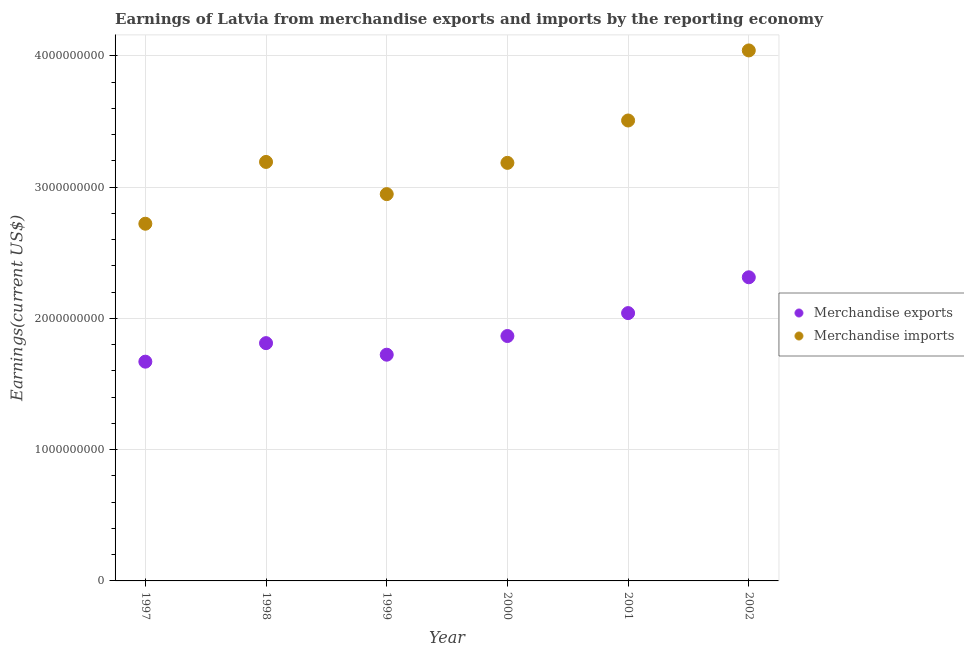How many different coloured dotlines are there?
Ensure brevity in your answer.  2. Is the number of dotlines equal to the number of legend labels?
Offer a very short reply. Yes. What is the earnings from merchandise imports in 1998?
Offer a terse response. 3.19e+09. Across all years, what is the maximum earnings from merchandise exports?
Your answer should be very brief. 2.31e+09. Across all years, what is the minimum earnings from merchandise imports?
Make the answer very short. 2.72e+09. In which year was the earnings from merchandise exports maximum?
Your answer should be very brief. 2002. What is the total earnings from merchandise exports in the graph?
Offer a very short reply. 1.14e+1. What is the difference between the earnings from merchandise exports in 1997 and that in 2001?
Make the answer very short. -3.70e+08. What is the difference between the earnings from merchandise exports in 2001 and the earnings from merchandise imports in 1999?
Provide a short and direct response. -9.06e+08. What is the average earnings from merchandise exports per year?
Give a very brief answer. 1.90e+09. In the year 2001, what is the difference between the earnings from merchandise exports and earnings from merchandise imports?
Keep it short and to the point. -1.47e+09. What is the ratio of the earnings from merchandise exports in 1998 to that in 2002?
Give a very brief answer. 0.78. Is the difference between the earnings from merchandise exports in 1997 and 1998 greater than the difference between the earnings from merchandise imports in 1997 and 1998?
Your response must be concise. Yes. What is the difference between the highest and the second highest earnings from merchandise exports?
Offer a very short reply. 2.73e+08. What is the difference between the highest and the lowest earnings from merchandise imports?
Keep it short and to the point. 1.32e+09. In how many years, is the earnings from merchandise imports greater than the average earnings from merchandise imports taken over all years?
Ensure brevity in your answer.  2. Is the sum of the earnings from merchandise imports in 1998 and 2001 greater than the maximum earnings from merchandise exports across all years?
Offer a very short reply. Yes. Is the earnings from merchandise imports strictly greater than the earnings from merchandise exports over the years?
Keep it short and to the point. Yes. Is the earnings from merchandise exports strictly less than the earnings from merchandise imports over the years?
Offer a very short reply. Yes. What is the difference between two consecutive major ticks on the Y-axis?
Make the answer very short. 1.00e+09. Does the graph contain grids?
Offer a very short reply. Yes. How many legend labels are there?
Give a very brief answer. 2. What is the title of the graph?
Keep it short and to the point. Earnings of Latvia from merchandise exports and imports by the reporting economy. Does "Start a business" appear as one of the legend labels in the graph?
Offer a very short reply. No. What is the label or title of the Y-axis?
Your response must be concise. Earnings(current US$). What is the Earnings(current US$) in Merchandise exports in 1997?
Make the answer very short. 1.67e+09. What is the Earnings(current US$) in Merchandise imports in 1997?
Make the answer very short. 2.72e+09. What is the Earnings(current US$) of Merchandise exports in 1998?
Your answer should be compact. 1.81e+09. What is the Earnings(current US$) in Merchandise imports in 1998?
Offer a terse response. 3.19e+09. What is the Earnings(current US$) in Merchandise exports in 1999?
Offer a terse response. 1.72e+09. What is the Earnings(current US$) of Merchandise imports in 1999?
Ensure brevity in your answer.  2.95e+09. What is the Earnings(current US$) of Merchandise exports in 2000?
Make the answer very short. 1.87e+09. What is the Earnings(current US$) of Merchandise imports in 2000?
Offer a terse response. 3.18e+09. What is the Earnings(current US$) in Merchandise exports in 2001?
Give a very brief answer. 2.04e+09. What is the Earnings(current US$) in Merchandise imports in 2001?
Keep it short and to the point. 3.51e+09. What is the Earnings(current US$) in Merchandise exports in 2002?
Your answer should be very brief. 2.31e+09. What is the Earnings(current US$) in Merchandise imports in 2002?
Give a very brief answer. 4.04e+09. Across all years, what is the maximum Earnings(current US$) in Merchandise exports?
Make the answer very short. 2.31e+09. Across all years, what is the maximum Earnings(current US$) in Merchandise imports?
Your response must be concise. 4.04e+09. Across all years, what is the minimum Earnings(current US$) in Merchandise exports?
Make the answer very short. 1.67e+09. Across all years, what is the minimum Earnings(current US$) of Merchandise imports?
Give a very brief answer. 2.72e+09. What is the total Earnings(current US$) of Merchandise exports in the graph?
Ensure brevity in your answer.  1.14e+1. What is the total Earnings(current US$) in Merchandise imports in the graph?
Keep it short and to the point. 1.96e+1. What is the difference between the Earnings(current US$) in Merchandise exports in 1997 and that in 1998?
Offer a very short reply. -1.41e+08. What is the difference between the Earnings(current US$) in Merchandise imports in 1997 and that in 1998?
Offer a terse response. -4.71e+08. What is the difference between the Earnings(current US$) in Merchandise exports in 1997 and that in 1999?
Your response must be concise. -5.31e+07. What is the difference between the Earnings(current US$) in Merchandise imports in 1997 and that in 1999?
Keep it short and to the point. -2.25e+08. What is the difference between the Earnings(current US$) of Merchandise exports in 1997 and that in 2000?
Give a very brief answer. -1.95e+08. What is the difference between the Earnings(current US$) of Merchandise imports in 1997 and that in 2000?
Offer a very short reply. -4.64e+08. What is the difference between the Earnings(current US$) of Merchandise exports in 1997 and that in 2001?
Keep it short and to the point. -3.70e+08. What is the difference between the Earnings(current US$) in Merchandise imports in 1997 and that in 2001?
Your response must be concise. -7.86e+08. What is the difference between the Earnings(current US$) in Merchandise exports in 1997 and that in 2002?
Ensure brevity in your answer.  -6.43e+08. What is the difference between the Earnings(current US$) of Merchandise imports in 1997 and that in 2002?
Ensure brevity in your answer.  -1.32e+09. What is the difference between the Earnings(current US$) in Merchandise exports in 1998 and that in 1999?
Ensure brevity in your answer.  8.81e+07. What is the difference between the Earnings(current US$) in Merchandise imports in 1998 and that in 1999?
Offer a terse response. 2.45e+08. What is the difference between the Earnings(current US$) in Merchandise exports in 1998 and that in 2000?
Provide a succinct answer. -5.42e+07. What is the difference between the Earnings(current US$) of Merchandise imports in 1998 and that in 2000?
Your answer should be compact. 7.06e+06. What is the difference between the Earnings(current US$) of Merchandise exports in 1998 and that in 2001?
Ensure brevity in your answer.  -2.29e+08. What is the difference between the Earnings(current US$) of Merchandise imports in 1998 and that in 2001?
Your response must be concise. -3.16e+08. What is the difference between the Earnings(current US$) of Merchandise exports in 1998 and that in 2002?
Provide a succinct answer. -5.02e+08. What is the difference between the Earnings(current US$) of Merchandise imports in 1998 and that in 2002?
Give a very brief answer. -8.49e+08. What is the difference between the Earnings(current US$) of Merchandise exports in 1999 and that in 2000?
Your answer should be compact. -1.42e+08. What is the difference between the Earnings(current US$) of Merchandise imports in 1999 and that in 2000?
Provide a succinct answer. -2.38e+08. What is the difference between the Earnings(current US$) of Merchandise exports in 1999 and that in 2001?
Provide a succinct answer. -3.17e+08. What is the difference between the Earnings(current US$) in Merchandise imports in 1999 and that in 2001?
Your answer should be compact. -5.61e+08. What is the difference between the Earnings(current US$) in Merchandise exports in 1999 and that in 2002?
Ensure brevity in your answer.  -5.90e+08. What is the difference between the Earnings(current US$) of Merchandise imports in 1999 and that in 2002?
Ensure brevity in your answer.  -1.09e+09. What is the difference between the Earnings(current US$) in Merchandise exports in 2000 and that in 2001?
Keep it short and to the point. -1.75e+08. What is the difference between the Earnings(current US$) in Merchandise imports in 2000 and that in 2001?
Your answer should be very brief. -3.23e+08. What is the difference between the Earnings(current US$) of Merchandise exports in 2000 and that in 2002?
Provide a short and direct response. -4.47e+08. What is the difference between the Earnings(current US$) in Merchandise imports in 2000 and that in 2002?
Provide a succinct answer. -8.56e+08. What is the difference between the Earnings(current US$) in Merchandise exports in 2001 and that in 2002?
Ensure brevity in your answer.  -2.73e+08. What is the difference between the Earnings(current US$) of Merchandise imports in 2001 and that in 2002?
Offer a very short reply. -5.34e+08. What is the difference between the Earnings(current US$) in Merchandise exports in 1997 and the Earnings(current US$) in Merchandise imports in 1998?
Provide a succinct answer. -1.52e+09. What is the difference between the Earnings(current US$) of Merchandise exports in 1997 and the Earnings(current US$) of Merchandise imports in 1999?
Make the answer very short. -1.28e+09. What is the difference between the Earnings(current US$) of Merchandise exports in 1997 and the Earnings(current US$) of Merchandise imports in 2000?
Keep it short and to the point. -1.51e+09. What is the difference between the Earnings(current US$) of Merchandise exports in 1997 and the Earnings(current US$) of Merchandise imports in 2001?
Provide a succinct answer. -1.84e+09. What is the difference between the Earnings(current US$) in Merchandise exports in 1997 and the Earnings(current US$) in Merchandise imports in 2002?
Ensure brevity in your answer.  -2.37e+09. What is the difference between the Earnings(current US$) in Merchandise exports in 1998 and the Earnings(current US$) in Merchandise imports in 1999?
Keep it short and to the point. -1.13e+09. What is the difference between the Earnings(current US$) in Merchandise exports in 1998 and the Earnings(current US$) in Merchandise imports in 2000?
Keep it short and to the point. -1.37e+09. What is the difference between the Earnings(current US$) of Merchandise exports in 1998 and the Earnings(current US$) of Merchandise imports in 2001?
Offer a terse response. -1.70e+09. What is the difference between the Earnings(current US$) of Merchandise exports in 1998 and the Earnings(current US$) of Merchandise imports in 2002?
Provide a succinct answer. -2.23e+09. What is the difference between the Earnings(current US$) in Merchandise exports in 1999 and the Earnings(current US$) in Merchandise imports in 2000?
Give a very brief answer. -1.46e+09. What is the difference between the Earnings(current US$) of Merchandise exports in 1999 and the Earnings(current US$) of Merchandise imports in 2001?
Your answer should be very brief. -1.78e+09. What is the difference between the Earnings(current US$) in Merchandise exports in 1999 and the Earnings(current US$) in Merchandise imports in 2002?
Make the answer very short. -2.32e+09. What is the difference between the Earnings(current US$) of Merchandise exports in 2000 and the Earnings(current US$) of Merchandise imports in 2001?
Offer a very short reply. -1.64e+09. What is the difference between the Earnings(current US$) in Merchandise exports in 2000 and the Earnings(current US$) in Merchandise imports in 2002?
Your answer should be very brief. -2.18e+09. What is the difference between the Earnings(current US$) of Merchandise exports in 2001 and the Earnings(current US$) of Merchandise imports in 2002?
Make the answer very short. -2.00e+09. What is the average Earnings(current US$) in Merchandise exports per year?
Offer a very short reply. 1.90e+09. What is the average Earnings(current US$) in Merchandise imports per year?
Give a very brief answer. 3.27e+09. In the year 1997, what is the difference between the Earnings(current US$) in Merchandise exports and Earnings(current US$) in Merchandise imports?
Your answer should be very brief. -1.05e+09. In the year 1998, what is the difference between the Earnings(current US$) in Merchandise exports and Earnings(current US$) in Merchandise imports?
Your answer should be very brief. -1.38e+09. In the year 1999, what is the difference between the Earnings(current US$) in Merchandise exports and Earnings(current US$) in Merchandise imports?
Provide a succinct answer. -1.22e+09. In the year 2000, what is the difference between the Earnings(current US$) of Merchandise exports and Earnings(current US$) of Merchandise imports?
Offer a very short reply. -1.32e+09. In the year 2001, what is the difference between the Earnings(current US$) of Merchandise exports and Earnings(current US$) of Merchandise imports?
Give a very brief answer. -1.47e+09. In the year 2002, what is the difference between the Earnings(current US$) in Merchandise exports and Earnings(current US$) in Merchandise imports?
Your response must be concise. -1.73e+09. What is the ratio of the Earnings(current US$) in Merchandise exports in 1997 to that in 1998?
Provide a succinct answer. 0.92. What is the ratio of the Earnings(current US$) of Merchandise imports in 1997 to that in 1998?
Offer a terse response. 0.85. What is the ratio of the Earnings(current US$) in Merchandise exports in 1997 to that in 1999?
Give a very brief answer. 0.97. What is the ratio of the Earnings(current US$) in Merchandise imports in 1997 to that in 1999?
Provide a succinct answer. 0.92. What is the ratio of the Earnings(current US$) of Merchandise exports in 1997 to that in 2000?
Offer a very short reply. 0.9. What is the ratio of the Earnings(current US$) in Merchandise imports in 1997 to that in 2000?
Your answer should be compact. 0.85. What is the ratio of the Earnings(current US$) of Merchandise exports in 1997 to that in 2001?
Your answer should be very brief. 0.82. What is the ratio of the Earnings(current US$) of Merchandise imports in 1997 to that in 2001?
Your response must be concise. 0.78. What is the ratio of the Earnings(current US$) of Merchandise exports in 1997 to that in 2002?
Give a very brief answer. 0.72. What is the ratio of the Earnings(current US$) of Merchandise imports in 1997 to that in 2002?
Your answer should be very brief. 0.67. What is the ratio of the Earnings(current US$) of Merchandise exports in 1998 to that in 1999?
Ensure brevity in your answer.  1.05. What is the ratio of the Earnings(current US$) of Merchandise imports in 1998 to that in 1999?
Offer a terse response. 1.08. What is the ratio of the Earnings(current US$) in Merchandise exports in 1998 to that in 2000?
Offer a terse response. 0.97. What is the ratio of the Earnings(current US$) of Merchandise exports in 1998 to that in 2001?
Offer a terse response. 0.89. What is the ratio of the Earnings(current US$) in Merchandise imports in 1998 to that in 2001?
Provide a succinct answer. 0.91. What is the ratio of the Earnings(current US$) of Merchandise exports in 1998 to that in 2002?
Your answer should be very brief. 0.78. What is the ratio of the Earnings(current US$) of Merchandise imports in 1998 to that in 2002?
Your response must be concise. 0.79. What is the ratio of the Earnings(current US$) of Merchandise exports in 1999 to that in 2000?
Keep it short and to the point. 0.92. What is the ratio of the Earnings(current US$) in Merchandise imports in 1999 to that in 2000?
Your answer should be very brief. 0.93. What is the ratio of the Earnings(current US$) of Merchandise exports in 1999 to that in 2001?
Provide a short and direct response. 0.84. What is the ratio of the Earnings(current US$) of Merchandise imports in 1999 to that in 2001?
Offer a very short reply. 0.84. What is the ratio of the Earnings(current US$) of Merchandise exports in 1999 to that in 2002?
Make the answer very short. 0.75. What is the ratio of the Earnings(current US$) in Merchandise imports in 1999 to that in 2002?
Your answer should be very brief. 0.73. What is the ratio of the Earnings(current US$) in Merchandise exports in 2000 to that in 2001?
Your answer should be compact. 0.91. What is the ratio of the Earnings(current US$) in Merchandise imports in 2000 to that in 2001?
Offer a terse response. 0.91. What is the ratio of the Earnings(current US$) in Merchandise exports in 2000 to that in 2002?
Your answer should be compact. 0.81. What is the ratio of the Earnings(current US$) of Merchandise imports in 2000 to that in 2002?
Offer a terse response. 0.79. What is the ratio of the Earnings(current US$) in Merchandise exports in 2001 to that in 2002?
Offer a very short reply. 0.88. What is the ratio of the Earnings(current US$) of Merchandise imports in 2001 to that in 2002?
Provide a succinct answer. 0.87. What is the difference between the highest and the second highest Earnings(current US$) in Merchandise exports?
Provide a short and direct response. 2.73e+08. What is the difference between the highest and the second highest Earnings(current US$) of Merchandise imports?
Your answer should be very brief. 5.34e+08. What is the difference between the highest and the lowest Earnings(current US$) in Merchandise exports?
Your answer should be very brief. 6.43e+08. What is the difference between the highest and the lowest Earnings(current US$) of Merchandise imports?
Provide a short and direct response. 1.32e+09. 